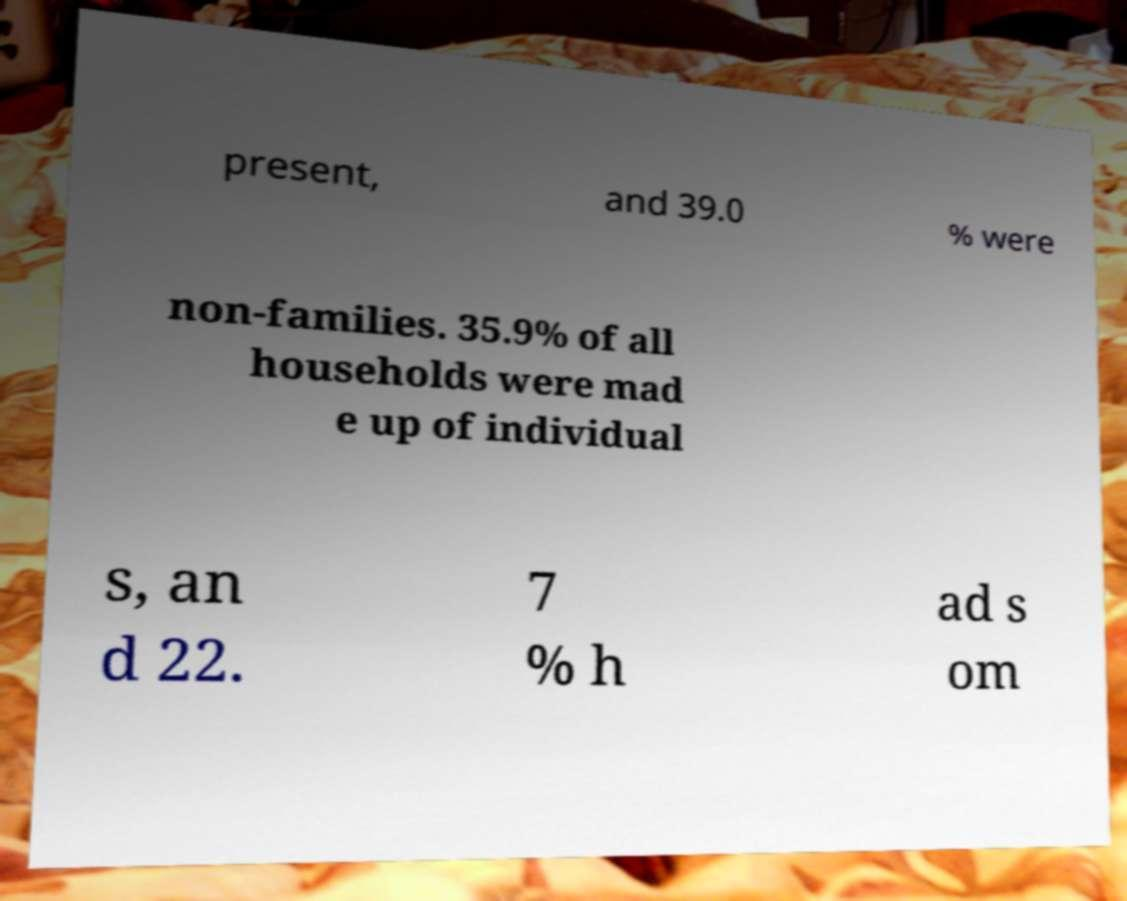Could you assist in decoding the text presented in this image and type it out clearly? present, and 39.0 % were non-families. 35.9% of all households were mad e up of individual s, an d 22. 7 % h ad s om 